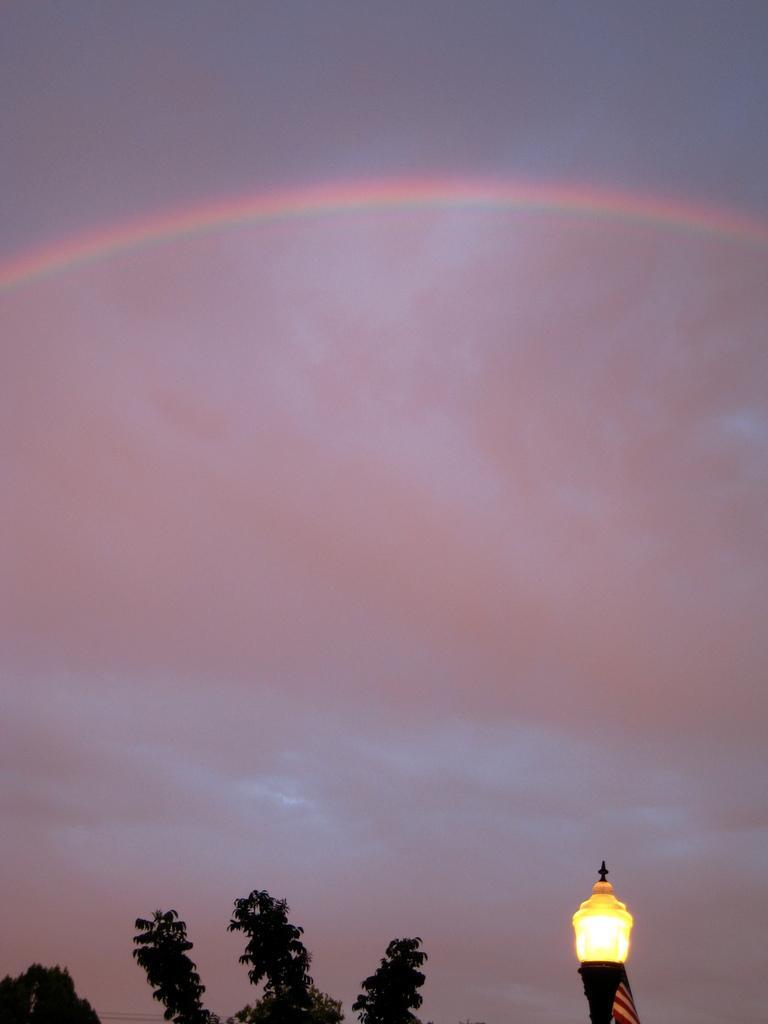Can you describe this image briefly? In this image I can see the tree. To the side I can see the light pole. In the background I can see the rainbow, clouds and the sky. 